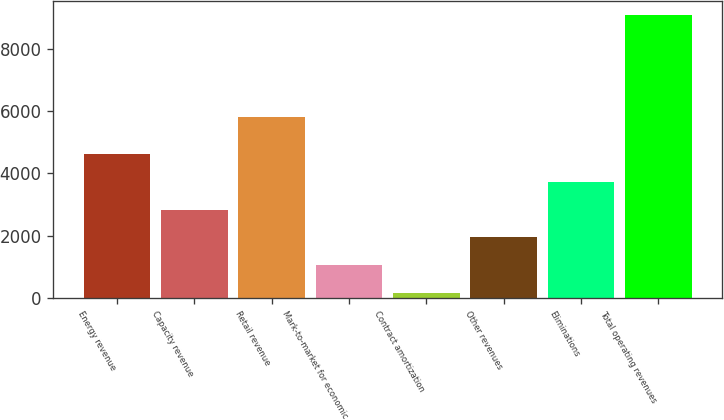Convert chart to OTSL. <chart><loc_0><loc_0><loc_500><loc_500><bar_chart><fcel>Energy revenue<fcel>Capacity revenue<fcel>Retail revenue<fcel>Mark-to-market for economic<fcel>Contract amortization<fcel>Other revenues<fcel>Eliminations<fcel>Total operating revenues<nl><fcel>4619<fcel>2835<fcel>5807<fcel>1051<fcel>159<fcel>1943<fcel>3727<fcel>9079<nl></chart> 